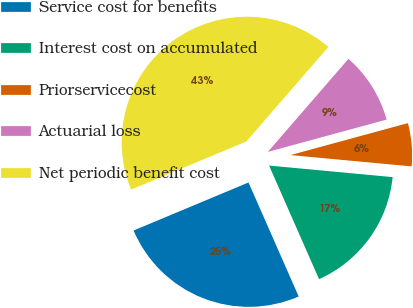Convert chart. <chart><loc_0><loc_0><loc_500><loc_500><pie_chart><fcel>Service cost for benefits<fcel>Interest cost on accumulated<fcel>Priorservicecost<fcel>Actuarial loss<fcel>Net periodic benefit cost<nl><fcel>25.3%<fcel>16.92%<fcel>5.71%<fcel>9.41%<fcel>42.67%<nl></chart> 